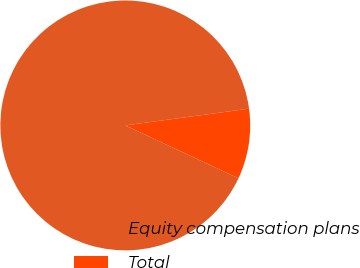Convert chart. <chart><loc_0><loc_0><loc_500><loc_500><pie_chart><fcel>Equity compensation plans<fcel>Total<nl><fcel>90.9%<fcel>9.1%<nl></chart> 